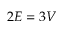Convert formula to latex. <formula><loc_0><loc_0><loc_500><loc_500>2 E = 3 V</formula> 